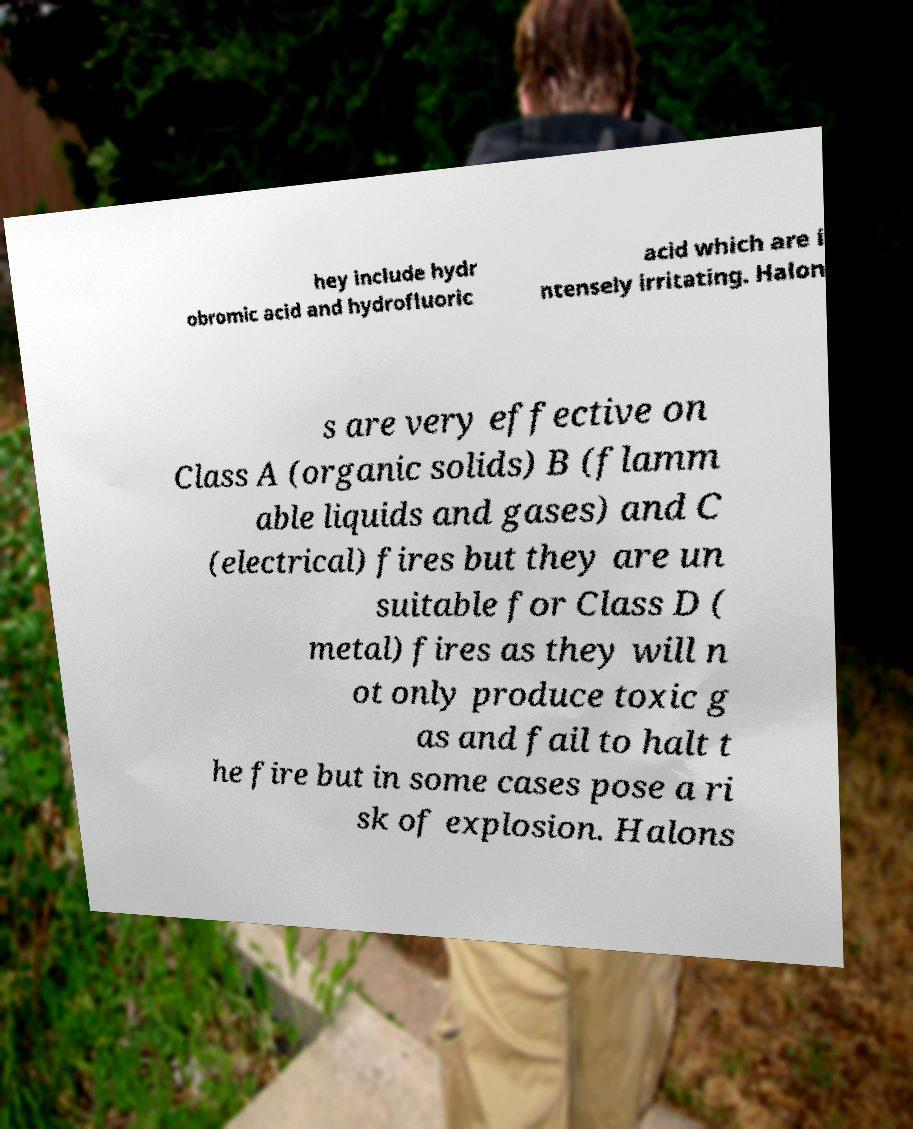Please read and relay the text visible in this image. What does it say? hey include hydr obromic acid and hydrofluoric acid which are i ntensely irritating. Halon s are very effective on Class A (organic solids) B (flamm able liquids and gases) and C (electrical) fires but they are un suitable for Class D ( metal) fires as they will n ot only produce toxic g as and fail to halt t he fire but in some cases pose a ri sk of explosion. Halons 